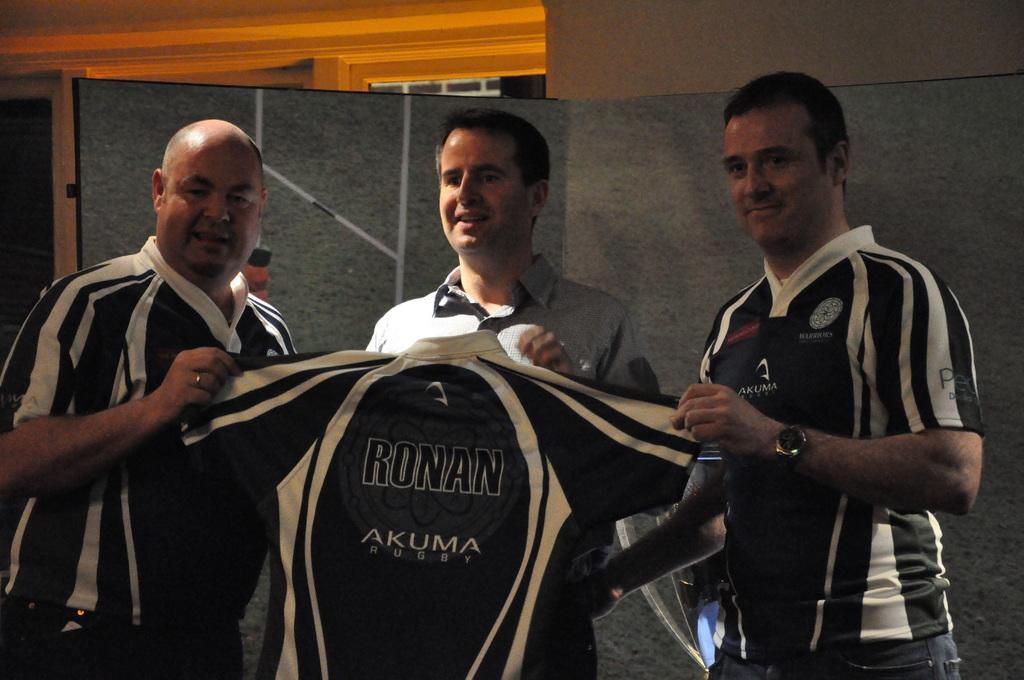<image>
Give a short and clear explanation of the subsequent image. Three men hold up a jersey that says Ronan and Akuma on it. 